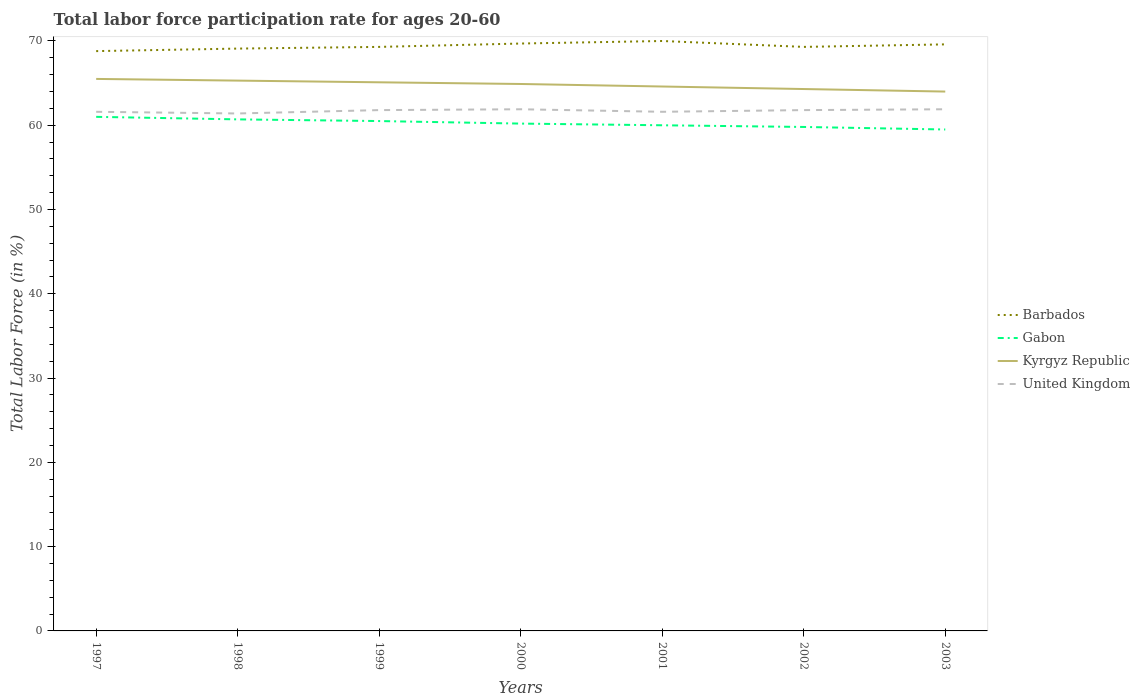Across all years, what is the maximum labor force participation rate in United Kingdom?
Your answer should be very brief. 61.4. In which year was the labor force participation rate in Kyrgyz Republic maximum?
Provide a short and direct response. 2003. What is the total labor force participation rate in Kyrgyz Republic in the graph?
Your answer should be compact. 0.2. What is the difference between the highest and the second highest labor force participation rate in Barbados?
Offer a terse response. 1.2. What is the difference between the highest and the lowest labor force participation rate in Kyrgyz Republic?
Your response must be concise. 4. Is the labor force participation rate in Gabon strictly greater than the labor force participation rate in United Kingdom over the years?
Your answer should be compact. Yes. How many years are there in the graph?
Your response must be concise. 7. What is the difference between two consecutive major ticks on the Y-axis?
Ensure brevity in your answer.  10. Are the values on the major ticks of Y-axis written in scientific E-notation?
Your response must be concise. No. Where does the legend appear in the graph?
Your response must be concise. Center right. How many legend labels are there?
Make the answer very short. 4. How are the legend labels stacked?
Give a very brief answer. Vertical. What is the title of the graph?
Make the answer very short. Total labor force participation rate for ages 20-60. What is the label or title of the X-axis?
Your answer should be very brief. Years. What is the label or title of the Y-axis?
Offer a terse response. Total Labor Force (in %). What is the Total Labor Force (in %) of Barbados in 1997?
Give a very brief answer. 68.8. What is the Total Labor Force (in %) in Gabon in 1997?
Make the answer very short. 61. What is the Total Labor Force (in %) in Kyrgyz Republic in 1997?
Your answer should be compact. 65.5. What is the Total Labor Force (in %) of United Kingdom in 1997?
Your answer should be very brief. 61.6. What is the Total Labor Force (in %) in Barbados in 1998?
Ensure brevity in your answer.  69.1. What is the Total Labor Force (in %) in Gabon in 1998?
Provide a succinct answer. 60.7. What is the Total Labor Force (in %) in Kyrgyz Republic in 1998?
Your answer should be very brief. 65.3. What is the Total Labor Force (in %) in United Kingdom in 1998?
Offer a terse response. 61.4. What is the Total Labor Force (in %) in Barbados in 1999?
Provide a succinct answer. 69.3. What is the Total Labor Force (in %) in Gabon in 1999?
Offer a terse response. 60.5. What is the Total Labor Force (in %) in Kyrgyz Republic in 1999?
Your response must be concise. 65.1. What is the Total Labor Force (in %) of United Kingdom in 1999?
Your response must be concise. 61.8. What is the Total Labor Force (in %) of Barbados in 2000?
Give a very brief answer. 69.7. What is the Total Labor Force (in %) in Gabon in 2000?
Make the answer very short. 60.2. What is the Total Labor Force (in %) of Kyrgyz Republic in 2000?
Make the answer very short. 64.9. What is the Total Labor Force (in %) of United Kingdom in 2000?
Provide a succinct answer. 61.9. What is the Total Labor Force (in %) in Barbados in 2001?
Your answer should be compact. 70. What is the Total Labor Force (in %) of Kyrgyz Republic in 2001?
Provide a succinct answer. 64.6. What is the Total Labor Force (in %) of United Kingdom in 2001?
Your answer should be very brief. 61.6. What is the Total Labor Force (in %) in Barbados in 2002?
Ensure brevity in your answer.  69.3. What is the Total Labor Force (in %) in Gabon in 2002?
Give a very brief answer. 59.8. What is the Total Labor Force (in %) of Kyrgyz Republic in 2002?
Provide a succinct answer. 64.3. What is the Total Labor Force (in %) in United Kingdom in 2002?
Make the answer very short. 61.8. What is the Total Labor Force (in %) of Barbados in 2003?
Give a very brief answer. 69.6. What is the Total Labor Force (in %) in Gabon in 2003?
Provide a succinct answer. 59.5. What is the Total Labor Force (in %) of Kyrgyz Republic in 2003?
Your answer should be very brief. 64. What is the Total Labor Force (in %) in United Kingdom in 2003?
Give a very brief answer. 61.9. Across all years, what is the maximum Total Labor Force (in %) of Kyrgyz Republic?
Provide a succinct answer. 65.5. Across all years, what is the maximum Total Labor Force (in %) of United Kingdom?
Keep it short and to the point. 61.9. Across all years, what is the minimum Total Labor Force (in %) in Barbados?
Offer a very short reply. 68.8. Across all years, what is the minimum Total Labor Force (in %) of Gabon?
Provide a succinct answer. 59.5. Across all years, what is the minimum Total Labor Force (in %) in Kyrgyz Republic?
Ensure brevity in your answer.  64. Across all years, what is the minimum Total Labor Force (in %) of United Kingdom?
Give a very brief answer. 61.4. What is the total Total Labor Force (in %) of Barbados in the graph?
Your answer should be very brief. 485.8. What is the total Total Labor Force (in %) in Gabon in the graph?
Offer a terse response. 421.7. What is the total Total Labor Force (in %) of Kyrgyz Republic in the graph?
Your answer should be compact. 453.7. What is the total Total Labor Force (in %) of United Kingdom in the graph?
Give a very brief answer. 432. What is the difference between the Total Labor Force (in %) of Barbados in 1997 and that in 1998?
Your answer should be very brief. -0.3. What is the difference between the Total Labor Force (in %) of Gabon in 1997 and that in 1998?
Your answer should be compact. 0.3. What is the difference between the Total Labor Force (in %) in Gabon in 1997 and that in 1999?
Your answer should be very brief. 0.5. What is the difference between the Total Labor Force (in %) in Kyrgyz Republic in 1997 and that in 1999?
Provide a succinct answer. 0.4. What is the difference between the Total Labor Force (in %) in United Kingdom in 1997 and that in 1999?
Your response must be concise. -0.2. What is the difference between the Total Labor Force (in %) of Barbados in 1997 and that in 2000?
Your answer should be compact. -0.9. What is the difference between the Total Labor Force (in %) in Kyrgyz Republic in 1997 and that in 2000?
Provide a succinct answer. 0.6. What is the difference between the Total Labor Force (in %) in Barbados in 1997 and that in 2002?
Ensure brevity in your answer.  -0.5. What is the difference between the Total Labor Force (in %) of Kyrgyz Republic in 1997 and that in 2002?
Your response must be concise. 1.2. What is the difference between the Total Labor Force (in %) in United Kingdom in 1997 and that in 2002?
Provide a short and direct response. -0.2. What is the difference between the Total Labor Force (in %) of Gabon in 1997 and that in 2003?
Make the answer very short. 1.5. What is the difference between the Total Labor Force (in %) of Barbados in 1998 and that in 1999?
Keep it short and to the point. -0.2. What is the difference between the Total Labor Force (in %) in Gabon in 1998 and that in 1999?
Your answer should be very brief. 0.2. What is the difference between the Total Labor Force (in %) in United Kingdom in 1998 and that in 1999?
Offer a very short reply. -0.4. What is the difference between the Total Labor Force (in %) in Gabon in 1998 and that in 2000?
Your response must be concise. 0.5. What is the difference between the Total Labor Force (in %) of Gabon in 1998 and that in 2001?
Your answer should be compact. 0.7. What is the difference between the Total Labor Force (in %) of Barbados in 1998 and that in 2002?
Make the answer very short. -0.2. What is the difference between the Total Labor Force (in %) in Barbados in 1998 and that in 2003?
Your answer should be very brief. -0.5. What is the difference between the Total Labor Force (in %) in Barbados in 1999 and that in 2000?
Make the answer very short. -0.4. What is the difference between the Total Labor Force (in %) of Kyrgyz Republic in 1999 and that in 2000?
Offer a terse response. 0.2. What is the difference between the Total Labor Force (in %) in Kyrgyz Republic in 1999 and that in 2001?
Offer a terse response. 0.5. What is the difference between the Total Labor Force (in %) in Barbados in 1999 and that in 2002?
Ensure brevity in your answer.  0. What is the difference between the Total Labor Force (in %) in Gabon in 1999 and that in 2002?
Provide a short and direct response. 0.7. What is the difference between the Total Labor Force (in %) in Kyrgyz Republic in 1999 and that in 2002?
Offer a terse response. 0.8. What is the difference between the Total Labor Force (in %) of Kyrgyz Republic in 1999 and that in 2003?
Give a very brief answer. 1.1. What is the difference between the Total Labor Force (in %) in United Kingdom in 1999 and that in 2003?
Ensure brevity in your answer.  -0.1. What is the difference between the Total Labor Force (in %) in Barbados in 2000 and that in 2001?
Make the answer very short. -0.3. What is the difference between the Total Labor Force (in %) in Gabon in 2000 and that in 2001?
Offer a very short reply. 0.2. What is the difference between the Total Labor Force (in %) of United Kingdom in 2000 and that in 2001?
Offer a terse response. 0.3. What is the difference between the Total Labor Force (in %) of Barbados in 2000 and that in 2002?
Provide a succinct answer. 0.4. What is the difference between the Total Labor Force (in %) of Gabon in 2000 and that in 2002?
Keep it short and to the point. 0.4. What is the difference between the Total Labor Force (in %) of Kyrgyz Republic in 2000 and that in 2002?
Provide a short and direct response. 0.6. What is the difference between the Total Labor Force (in %) in United Kingdom in 2000 and that in 2002?
Your answer should be very brief. 0.1. What is the difference between the Total Labor Force (in %) of Gabon in 2000 and that in 2003?
Your response must be concise. 0.7. What is the difference between the Total Labor Force (in %) in Kyrgyz Republic in 2000 and that in 2003?
Provide a short and direct response. 0.9. What is the difference between the Total Labor Force (in %) in Kyrgyz Republic in 2001 and that in 2002?
Give a very brief answer. 0.3. What is the difference between the Total Labor Force (in %) of United Kingdom in 2001 and that in 2002?
Give a very brief answer. -0.2. What is the difference between the Total Labor Force (in %) in Kyrgyz Republic in 2001 and that in 2003?
Your answer should be compact. 0.6. What is the difference between the Total Labor Force (in %) of United Kingdom in 2001 and that in 2003?
Your response must be concise. -0.3. What is the difference between the Total Labor Force (in %) of Barbados in 2002 and that in 2003?
Make the answer very short. -0.3. What is the difference between the Total Labor Force (in %) of United Kingdom in 2002 and that in 2003?
Give a very brief answer. -0.1. What is the difference between the Total Labor Force (in %) in Barbados in 1997 and the Total Labor Force (in %) in United Kingdom in 1998?
Offer a very short reply. 7.4. What is the difference between the Total Labor Force (in %) in Gabon in 1997 and the Total Labor Force (in %) in Kyrgyz Republic in 1998?
Offer a terse response. -4.3. What is the difference between the Total Labor Force (in %) in Barbados in 1997 and the Total Labor Force (in %) in Gabon in 1999?
Ensure brevity in your answer.  8.3. What is the difference between the Total Labor Force (in %) of Barbados in 1997 and the Total Labor Force (in %) of Kyrgyz Republic in 1999?
Your answer should be compact. 3.7. What is the difference between the Total Labor Force (in %) of Gabon in 1997 and the Total Labor Force (in %) of Kyrgyz Republic in 1999?
Your response must be concise. -4.1. What is the difference between the Total Labor Force (in %) of Gabon in 1997 and the Total Labor Force (in %) of United Kingdom in 1999?
Ensure brevity in your answer.  -0.8. What is the difference between the Total Labor Force (in %) in Barbados in 1997 and the Total Labor Force (in %) in Kyrgyz Republic in 2000?
Your answer should be very brief. 3.9. What is the difference between the Total Labor Force (in %) of Barbados in 1997 and the Total Labor Force (in %) of Gabon in 2001?
Your answer should be compact. 8.8. What is the difference between the Total Labor Force (in %) of Barbados in 1997 and the Total Labor Force (in %) of Kyrgyz Republic in 2001?
Provide a short and direct response. 4.2. What is the difference between the Total Labor Force (in %) in Barbados in 1997 and the Total Labor Force (in %) in United Kingdom in 2001?
Make the answer very short. 7.2. What is the difference between the Total Labor Force (in %) in Kyrgyz Republic in 1997 and the Total Labor Force (in %) in United Kingdom in 2001?
Give a very brief answer. 3.9. What is the difference between the Total Labor Force (in %) of Barbados in 1997 and the Total Labor Force (in %) of Gabon in 2002?
Offer a very short reply. 9. What is the difference between the Total Labor Force (in %) in Barbados in 1997 and the Total Labor Force (in %) in United Kingdom in 2002?
Keep it short and to the point. 7. What is the difference between the Total Labor Force (in %) in Gabon in 1997 and the Total Labor Force (in %) in United Kingdom in 2002?
Keep it short and to the point. -0.8. What is the difference between the Total Labor Force (in %) of Kyrgyz Republic in 1997 and the Total Labor Force (in %) of United Kingdom in 2002?
Offer a very short reply. 3.7. What is the difference between the Total Labor Force (in %) of Kyrgyz Republic in 1997 and the Total Labor Force (in %) of United Kingdom in 2003?
Offer a very short reply. 3.6. What is the difference between the Total Labor Force (in %) in Barbados in 1998 and the Total Labor Force (in %) in Gabon in 1999?
Provide a succinct answer. 8.6. What is the difference between the Total Labor Force (in %) of Barbados in 1998 and the Total Labor Force (in %) of United Kingdom in 1999?
Your answer should be very brief. 7.3. What is the difference between the Total Labor Force (in %) of Gabon in 1998 and the Total Labor Force (in %) of Kyrgyz Republic in 1999?
Your answer should be very brief. -4.4. What is the difference between the Total Labor Force (in %) in Gabon in 1998 and the Total Labor Force (in %) in United Kingdom in 1999?
Provide a succinct answer. -1.1. What is the difference between the Total Labor Force (in %) of Barbados in 1998 and the Total Labor Force (in %) of United Kingdom in 2000?
Offer a terse response. 7.2. What is the difference between the Total Labor Force (in %) of Gabon in 1998 and the Total Labor Force (in %) of Kyrgyz Republic in 2000?
Provide a short and direct response. -4.2. What is the difference between the Total Labor Force (in %) of Gabon in 1998 and the Total Labor Force (in %) of United Kingdom in 2000?
Give a very brief answer. -1.2. What is the difference between the Total Labor Force (in %) in Kyrgyz Republic in 1998 and the Total Labor Force (in %) in United Kingdom in 2000?
Offer a terse response. 3.4. What is the difference between the Total Labor Force (in %) in Barbados in 1998 and the Total Labor Force (in %) in Gabon in 2001?
Offer a very short reply. 9.1. What is the difference between the Total Labor Force (in %) of Barbados in 1998 and the Total Labor Force (in %) of United Kingdom in 2001?
Make the answer very short. 7.5. What is the difference between the Total Labor Force (in %) in Kyrgyz Republic in 1998 and the Total Labor Force (in %) in United Kingdom in 2001?
Provide a succinct answer. 3.7. What is the difference between the Total Labor Force (in %) in Barbados in 1998 and the Total Labor Force (in %) in Kyrgyz Republic in 2002?
Ensure brevity in your answer.  4.8. What is the difference between the Total Labor Force (in %) in Barbados in 1998 and the Total Labor Force (in %) in United Kingdom in 2002?
Keep it short and to the point. 7.3. What is the difference between the Total Labor Force (in %) of Gabon in 1998 and the Total Labor Force (in %) of Kyrgyz Republic in 2002?
Your answer should be very brief. -3.6. What is the difference between the Total Labor Force (in %) in Kyrgyz Republic in 1998 and the Total Labor Force (in %) in United Kingdom in 2002?
Offer a terse response. 3.5. What is the difference between the Total Labor Force (in %) in Barbados in 1998 and the Total Labor Force (in %) in Gabon in 2003?
Make the answer very short. 9.6. What is the difference between the Total Labor Force (in %) of Kyrgyz Republic in 1998 and the Total Labor Force (in %) of United Kingdom in 2003?
Your response must be concise. 3.4. What is the difference between the Total Labor Force (in %) of Barbados in 1999 and the Total Labor Force (in %) of Gabon in 2000?
Ensure brevity in your answer.  9.1. What is the difference between the Total Labor Force (in %) in Barbados in 1999 and the Total Labor Force (in %) in Kyrgyz Republic in 2000?
Give a very brief answer. 4.4. What is the difference between the Total Labor Force (in %) of Gabon in 1999 and the Total Labor Force (in %) of Kyrgyz Republic in 2000?
Give a very brief answer. -4.4. What is the difference between the Total Labor Force (in %) of Gabon in 1999 and the Total Labor Force (in %) of United Kingdom in 2000?
Provide a short and direct response. -1.4. What is the difference between the Total Labor Force (in %) in Kyrgyz Republic in 1999 and the Total Labor Force (in %) in United Kingdom in 2000?
Your response must be concise. 3.2. What is the difference between the Total Labor Force (in %) of Barbados in 1999 and the Total Labor Force (in %) of Kyrgyz Republic in 2001?
Offer a terse response. 4.7. What is the difference between the Total Labor Force (in %) in Gabon in 1999 and the Total Labor Force (in %) in United Kingdom in 2001?
Your answer should be compact. -1.1. What is the difference between the Total Labor Force (in %) in Barbados in 1999 and the Total Labor Force (in %) in Gabon in 2002?
Provide a short and direct response. 9.5. What is the difference between the Total Labor Force (in %) of Gabon in 1999 and the Total Labor Force (in %) of Kyrgyz Republic in 2002?
Your response must be concise. -3.8. What is the difference between the Total Labor Force (in %) in Gabon in 1999 and the Total Labor Force (in %) in United Kingdom in 2002?
Your answer should be very brief. -1.3. What is the difference between the Total Labor Force (in %) of Kyrgyz Republic in 1999 and the Total Labor Force (in %) of United Kingdom in 2002?
Ensure brevity in your answer.  3.3. What is the difference between the Total Labor Force (in %) in Barbados in 1999 and the Total Labor Force (in %) in Gabon in 2003?
Provide a succinct answer. 9.8. What is the difference between the Total Labor Force (in %) in Barbados in 1999 and the Total Labor Force (in %) in Kyrgyz Republic in 2003?
Ensure brevity in your answer.  5.3. What is the difference between the Total Labor Force (in %) of Barbados in 1999 and the Total Labor Force (in %) of United Kingdom in 2003?
Ensure brevity in your answer.  7.4. What is the difference between the Total Labor Force (in %) in Gabon in 1999 and the Total Labor Force (in %) in Kyrgyz Republic in 2003?
Give a very brief answer. -3.5. What is the difference between the Total Labor Force (in %) in Gabon in 1999 and the Total Labor Force (in %) in United Kingdom in 2003?
Keep it short and to the point. -1.4. What is the difference between the Total Labor Force (in %) in Kyrgyz Republic in 1999 and the Total Labor Force (in %) in United Kingdom in 2003?
Your response must be concise. 3.2. What is the difference between the Total Labor Force (in %) of Barbados in 2000 and the Total Labor Force (in %) of Gabon in 2001?
Give a very brief answer. 9.7. What is the difference between the Total Labor Force (in %) in Gabon in 2000 and the Total Labor Force (in %) in Kyrgyz Republic in 2001?
Offer a terse response. -4.4. What is the difference between the Total Labor Force (in %) of Gabon in 2000 and the Total Labor Force (in %) of United Kingdom in 2001?
Keep it short and to the point. -1.4. What is the difference between the Total Labor Force (in %) in Kyrgyz Republic in 2000 and the Total Labor Force (in %) in United Kingdom in 2001?
Provide a succinct answer. 3.3. What is the difference between the Total Labor Force (in %) of Gabon in 2000 and the Total Labor Force (in %) of Kyrgyz Republic in 2002?
Give a very brief answer. -4.1. What is the difference between the Total Labor Force (in %) in Kyrgyz Republic in 2000 and the Total Labor Force (in %) in United Kingdom in 2002?
Ensure brevity in your answer.  3.1. What is the difference between the Total Labor Force (in %) of Barbados in 2000 and the Total Labor Force (in %) of Kyrgyz Republic in 2003?
Give a very brief answer. 5.7. What is the difference between the Total Labor Force (in %) in Gabon in 2000 and the Total Labor Force (in %) in United Kingdom in 2003?
Your answer should be compact. -1.7. What is the difference between the Total Labor Force (in %) of Kyrgyz Republic in 2000 and the Total Labor Force (in %) of United Kingdom in 2003?
Your response must be concise. 3. What is the difference between the Total Labor Force (in %) of Barbados in 2001 and the Total Labor Force (in %) of United Kingdom in 2002?
Ensure brevity in your answer.  8.2. What is the difference between the Total Labor Force (in %) of Kyrgyz Republic in 2001 and the Total Labor Force (in %) of United Kingdom in 2002?
Your answer should be compact. 2.8. What is the difference between the Total Labor Force (in %) in Barbados in 2001 and the Total Labor Force (in %) in Gabon in 2003?
Your answer should be compact. 10.5. What is the difference between the Total Labor Force (in %) in Barbados in 2001 and the Total Labor Force (in %) in Kyrgyz Republic in 2003?
Provide a short and direct response. 6. What is the difference between the Total Labor Force (in %) in Gabon in 2001 and the Total Labor Force (in %) in Kyrgyz Republic in 2003?
Give a very brief answer. -4. What is the difference between the Total Labor Force (in %) in Gabon in 2001 and the Total Labor Force (in %) in United Kingdom in 2003?
Offer a very short reply. -1.9. What is the difference between the Total Labor Force (in %) in Kyrgyz Republic in 2001 and the Total Labor Force (in %) in United Kingdom in 2003?
Offer a terse response. 2.7. What is the difference between the Total Labor Force (in %) in Barbados in 2002 and the Total Labor Force (in %) in Gabon in 2003?
Provide a short and direct response. 9.8. What is the difference between the Total Labor Force (in %) in Barbados in 2002 and the Total Labor Force (in %) in United Kingdom in 2003?
Provide a short and direct response. 7.4. What is the average Total Labor Force (in %) in Barbados per year?
Your answer should be compact. 69.4. What is the average Total Labor Force (in %) of Gabon per year?
Your answer should be very brief. 60.24. What is the average Total Labor Force (in %) in Kyrgyz Republic per year?
Keep it short and to the point. 64.81. What is the average Total Labor Force (in %) in United Kingdom per year?
Keep it short and to the point. 61.71. In the year 1997, what is the difference between the Total Labor Force (in %) in Barbados and Total Labor Force (in %) in Kyrgyz Republic?
Provide a short and direct response. 3.3. In the year 1997, what is the difference between the Total Labor Force (in %) in Barbados and Total Labor Force (in %) in United Kingdom?
Your response must be concise. 7.2. In the year 1998, what is the difference between the Total Labor Force (in %) of Barbados and Total Labor Force (in %) of Gabon?
Offer a terse response. 8.4. In the year 1998, what is the difference between the Total Labor Force (in %) in Barbados and Total Labor Force (in %) in United Kingdom?
Your answer should be compact. 7.7. In the year 2000, what is the difference between the Total Labor Force (in %) in Barbados and Total Labor Force (in %) in Gabon?
Your answer should be compact. 9.5. In the year 2000, what is the difference between the Total Labor Force (in %) of Barbados and Total Labor Force (in %) of Kyrgyz Republic?
Your answer should be very brief. 4.8. In the year 2000, what is the difference between the Total Labor Force (in %) of Gabon and Total Labor Force (in %) of Kyrgyz Republic?
Make the answer very short. -4.7. In the year 2000, what is the difference between the Total Labor Force (in %) in Gabon and Total Labor Force (in %) in United Kingdom?
Provide a short and direct response. -1.7. In the year 2000, what is the difference between the Total Labor Force (in %) of Kyrgyz Republic and Total Labor Force (in %) of United Kingdom?
Your answer should be compact. 3. In the year 2001, what is the difference between the Total Labor Force (in %) of Barbados and Total Labor Force (in %) of Gabon?
Your answer should be compact. 10. In the year 2002, what is the difference between the Total Labor Force (in %) of Barbados and Total Labor Force (in %) of Gabon?
Offer a terse response. 9.5. In the year 2002, what is the difference between the Total Labor Force (in %) of Barbados and Total Labor Force (in %) of Kyrgyz Republic?
Give a very brief answer. 5. In the year 2002, what is the difference between the Total Labor Force (in %) in Barbados and Total Labor Force (in %) in United Kingdom?
Offer a terse response. 7.5. In the year 2002, what is the difference between the Total Labor Force (in %) in Gabon and Total Labor Force (in %) in Kyrgyz Republic?
Your answer should be very brief. -4.5. In the year 2003, what is the difference between the Total Labor Force (in %) of Barbados and Total Labor Force (in %) of Kyrgyz Republic?
Make the answer very short. 5.6. In the year 2003, what is the difference between the Total Labor Force (in %) in Gabon and Total Labor Force (in %) in United Kingdom?
Provide a short and direct response. -2.4. In the year 2003, what is the difference between the Total Labor Force (in %) in Kyrgyz Republic and Total Labor Force (in %) in United Kingdom?
Provide a short and direct response. 2.1. What is the ratio of the Total Labor Force (in %) of Gabon in 1997 to that in 1998?
Ensure brevity in your answer.  1. What is the ratio of the Total Labor Force (in %) in Gabon in 1997 to that in 1999?
Your answer should be very brief. 1.01. What is the ratio of the Total Labor Force (in %) in United Kingdom in 1997 to that in 1999?
Offer a terse response. 1. What is the ratio of the Total Labor Force (in %) of Barbados in 1997 to that in 2000?
Offer a terse response. 0.99. What is the ratio of the Total Labor Force (in %) in Gabon in 1997 to that in 2000?
Your answer should be compact. 1.01. What is the ratio of the Total Labor Force (in %) in Kyrgyz Republic in 1997 to that in 2000?
Offer a very short reply. 1.01. What is the ratio of the Total Labor Force (in %) of Barbados in 1997 to that in 2001?
Provide a short and direct response. 0.98. What is the ratio of the Total Labor Force (in %) in Gabon in 1997 to that in 2001?
Provide a short and direct response. 1.02. What is the ratio of the Total Labor Force (in %) in Kyrgyz Republic in 1997 to that in 2001?
Offer a terse response. 1.01. What is the ratio of the Total Labor Force (in %) of Barbados in 1997 to that in 2002?
Give a very brief answer. 0.99. What is the ratio of the Total Labor Force (in %) of Gabon in 1997 to that in 2002?
Offer a very short reply. 1.02. What is the ratio of the Total Labor Force (in %) of Kyrgyz Republic in 1997 to that in 2002?
Provide a succinct answer. 1.02. What is the ratio of the Total Labor Force (in %) in Gabon in 1997 to that in 2003?
Offer a terse response. 1.03. What is the ratio of the Total Labor Force (in %) of Kyrgyz Republic in 1997 to that in 2003?
Make the answer very short. 1.02. What is the ratio of the Total Labor Force (in %) of United Kingdom in 1997 to that in 2003?
Ensure brevity in your answer.  1. What is the ratio of the Total Labor Force (in %) in Barbados in 1998 to that in 1999?
Keep it short and to the point. 1. What is the ratio of the Total Labor Force (in %) in United Kingdom in 1998 to that in 1999?
Your response must be concise. 0.99. What is the ratio of the Total Labor Force (in %) of Gabon in 1998 to that in 2000?
Provide a succinct answer. 1.01. What is the ratio of the Total Labor Force (in %) of Kyrgyz Republic in 1998 to that in 2000?
Your answer should be compact. 1.01. What is the ratio of the Total Labor Force (in %) of United Kingdom in 1998 to that in 2000?
Your response must be concise. 0.99. What is the ratio of the Total Labor Force (in %) in Barbados in 1998 to that in 2001?
Offer a terse response. 0.99. What is the ratio of the Total Labor Force (in %) of Gabon in 1998 to that in 2001?
Your answer should be compact. 1.01. What is the ratio of the Total Labor Force (in %) of Kyrgyz Republic in 1998 to that in 2001?
Give a very brief answer. 1.01. What is the ratio of the Total Labor Force (in %) in United Kingdom in 1998 to that in 2001?
Offer a terse response. 1. What is the ratio of the Total Labor Force (in %) of Barbados in 1998 to that in 2002?
Keep it short and to the point. 1. What is the ratio of the Total Labor Force (in %) of Gabon in 1998 to that in 2002?
Your response must be concise. 1.02. What is the ratio of the Total Labor Force (in %) in Kyrgyz Republic in 1998 to that in 2002?
Make the answer very short. 1.02. What is the ratio of the Total Labor Force (in %) of United Kingdom in 1998 to that in 2002?
Your response must be concise. 0.99. What is the ratio of the Total Labor Force (in %) of Barbados in 1998 to that in 2003?
Offer a very short reply. 0.99. What is the ratio of the Total Labor Force (in %) of Gabon in 1998 to that in 2003?
Provide a succinct answer. 1.02. What is the ratio of the Total Labor Force (in %) of Kyrgyz Republic in 1998 to that in 2003?
Keep it short and to the point. 1.02. What is the ratio of the Total Labor Force (in %) of Kyrgyz Republic in 1999 to that in 2000?
Give a very brief answer. 1. What is the ratio of the Total Labor Force (in %) in United Kingdom in 1999 to that in 2000?
Provide a short and direct response. 1. What is the ratio of the Total Labor Force (in %) of Barbados in 1999 to that in 2001?
Your answer should be very brief. 0.99. What is the ratio of the Total Labor Force (in %) of Gabon in 1999 to that in 2001?
Make the answer very short. 1.01. What is the ratio of the Total Labor Force (in %) in Kyrgyz Republic in 1999 to that in 2001?
Make the answer very short. 1.01. What is the ratio of the Total Labor Force (in %) of Gabon in 1999 to that in 2002?
Keep it short and to the point. 1.01. What is the ratio of the Total Labor Force (in %) of Kyrgyz Republic in 1999 to that in 2002?
Your answer should be very brief. 1.01. What is the ratio of the Total Labor Force (in %) of Gabon in 1999 to that in 2003?
Offer a very short reply. 1.02. What is the ratio of the Total Labor Force (in %) of Kyrgyz Republic in 1999 to that in 2003?
Offer a very short reply. 1.02. What is the ratio of the Total Labor Force (in %) in United Kingdom in 1999 to that in 2003?
Make the answer very short. 1. What is the ratio of the Total Labor Force (in %) of Barbados in 2000 to that in 2001?
Keep it short and to the point. 1. What is the ratio of the Total Labor Force (in %) of Kyrgyz Republic in 2000 to that in 2001?
Provide a succinct answer. 1. What is the ratio of the Total Labor Force (in %) of United Kingdom in 2000 to that in 2001?
Your answer should be compact. 1. What is the ratio of the Total Labor Force (in %) of Gabon in 2000 to that in 2002?
Keep it short and to the point. 1.01. What is the ratio of the Total Labor Force (in %) of Kyrgyz Republic in 2000 to that in 2002?
Provide a short and direct response. 1.01. What is the ratio of the Total Labor Force (in %) in United Kingdom in 2000 to that in 2002?
Offer a very short reply. 1. What is the ratio of the Total Labor Force (in %) of Barbados in 2000 to that in 2003?
Offer a terse response. 1. What is the ratio of the Total Labor Force (in %) in Gabon in 2000 to that in 2003?
Offer a terse response. 1.01. What is the ratio of the Total Labor Force (in %) in Kyrgyz Republic in 2000 to that in 2003?
Your answer should be compact. 1.01. What is the ratio of the Total Labor Force (in %) of United Kingdom in 2000 to that in 2003?
Give a very brief answer. 1. What is the ratio of the Total Labor Force (in %) of United Kingdom in 2001 to that in 2002?
Provide a short and direct response. 1. What is the ratio of the Total Labor Force (in %) of Barbados in 2001 to that in 2003?
Offer a very short reply. 1.01. What is the ratio of the Total Labor Force (in %) of Gabon in 2001 to that in 2003?
Your answer should be compact. 1.01. What is the ratio of the Total Labor Force (in %) in Kyrgyz Republic in 2001 to that in 2003?
Your response must be concise. 1.01. What is the ratio of the Total Labor Force (in %) in Gabon in 2002 to that in 2003?
Your answer should be compact. 1. What is the ratio of the Total Labor Force (in %) in Kyrgyz Republic in 2002 to that in 2003?
Your answer should be very brief. 1. What is the ratio of the Total Labor Force (in %) of United Kingdom in 2002 to that in 2003?
Offer a terse response. 1. What is the difference between the highest and the second highest Total Labor Force (in %) in Barbados?
Give a very brief answer. 0.3. What is the difference between the highest and the second highest Total Labor Force (in %) of Gabon?
Offer a terse response. 0.3. What is the difference between the highest and the second highest Total Labor Force (in %) in Kyrgyz Republic?
Make the answer very short. 0.2. What is the difference between the highest and the lowest Total Labor Force (in %) in Barbados?
Give a very brief answer. 1.2. What is the difference between the highest and the lowest Total Labor Force (in %) of United Kingdom?
Your answer should be very brief. 0.5. 